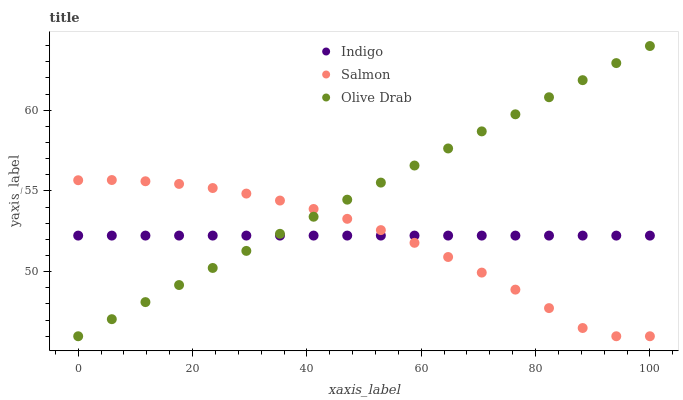Does Salmon have the minimum area under the curve?
Answer yes or no. Yes. Does Olive Drab have the maximum area under the curve?
Answer yes or no. Yes. Does Indigo have the minimum area under the curve?
Answer yes or no. No. Does Indigo have the maximum area under the curve?
Answer yes or no. No. Is Olive Drab the smoothest?
Answer yes or no. Yes. Is Salmon the roughest?
Answer yes or no. Yes. Is Indigo the smoothest?
Answer yes or no. No. Is Indigo the roughest?
Answer yes or no. No. Does Salmon have the lowest value?
Answer yes or no. Yes. Does Indigo have the lowest value?
Answer yes or no. No. Does Olive Drab have the highest value?
Answer yes or no. Yes. Does Indigo have the highest value?
Answer yes or no. No. Does Salmon intersect Olive Drab?
Answer yes or no. Yes. Is Salmon less than Olive Drab?
Answer yes or no. No. Is Salmon greater than Olive Drab?
Answer yes or no. No. 